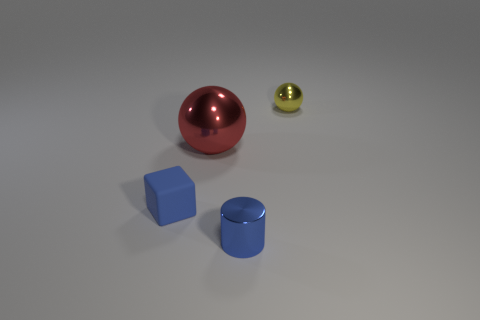Is there anything else that is the same size as the red metallic ball?
Give a very brief answer. No. How many objects are both on the left side of the tiny blue cylinder and behind the small cube?
Keep it short and to the point. 1. What is the material of the tiny object behind the small blue block that is to the left of the tiny blue thing that is on the right side of the rubber thing?
Your response must be concise. Metal. How many big spheres have the same material as the big red thing?
Your answer should be very brief. 0. There is a small metal object that is the same color as the cube; what shape is it?
Offer a terse response. Cylinder. There is a yellow metal object that is the same size as the blue matte cube; what shape is it?
Give a very brief answer. Sphere. There is a thing that is the same color as the small cylinder; what is it made of?
Keep it short and to the point. Rubber. There is a big red thing; are there any yellow things in front of it?
Your response must be concise. No. Is there a small yellow metallic object that has the same shape as the large shiny thing?
Give a very brief answer. Yes. There is a small blue rubber thing that is to the left of the small yellow metal object; is its shape the same as the metal thing in front of the tiny rubber cube?
Give a very brief answer. No. 